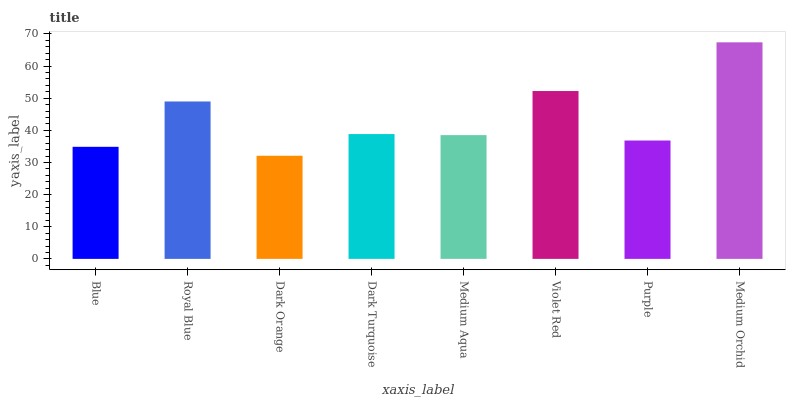Is Dark Orange the minimum?
Answer yes or no. Yes. Is Medium Orchid the maximum?
Answer yes or no. Yes. Is Royal Blue the minimum?
Answer yes or no. No. Is Royal Blue the maximum?
Answer yes or no. No. Is Royal Blue greater than Blue?
Answer yes or no. Yes. Is Blue less than Royal Blue?
Answer yes or no. Yes. Is Blue greater than Royal Blue?
Answer yes or no. No. Is Royal Blue less than Blue?
Answer yes or no. No. Is Dark Turquoise the high median?
Answer yes or no. Yes. Is Medium Aqua the low median?
Answer yes or no. Yes. Is Medium Aqua the high median?
Answer yes or no. No. Is Royal Blue the low median?
Answer yes or no. No. 